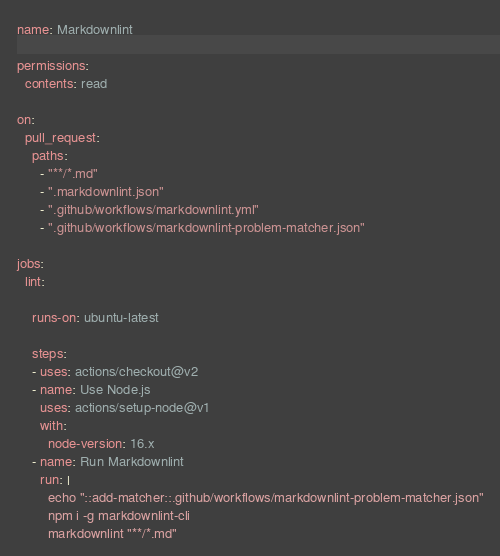<code> <loc_0><loc_0><loc_500><loc_500><_YAML_>name: Markdownlint

permissions:
  contents: read

on:
  pull_request:
    paths:
      - "**/*.md"
      - ".markdownlint.json"
      - ".github/workflows/markdownlint.yml"
      - ".github/workflows/markdownlint-problem-matcher.json"

jobs:
  lint:

    runs-on: ubuntu-latest

    steps:
    - uses: actions/checkout@v2
    - name: Use Node.js
      uses: actions/setup-node@v1
      with:
        node-version: 16.x
    - name: Run Markdownlint
      run: |
        echo "::add-matcher::.github/workflows/markdownlint-problem-matcher.json"
        npm i -g markdownlint-cli
        markdownlint "**/*.md"
</code> 